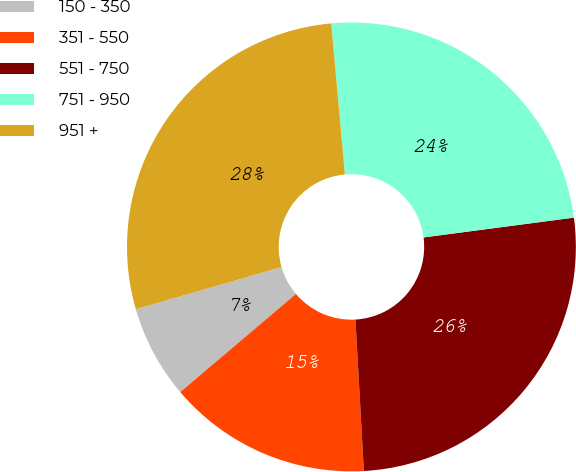<chart> <loc_0><loc_0><loc_500><loc_500><pie_chart><fcel>150 - 350<fcel>351 - 550<fcel>551 - 750<fcel>751 - 950<fcel>951 +<nl><fcel>6.72%<fcel>14.69%<fcel>26.2%<fcel>24.35%<fcel>28.04%<nl></chart> 